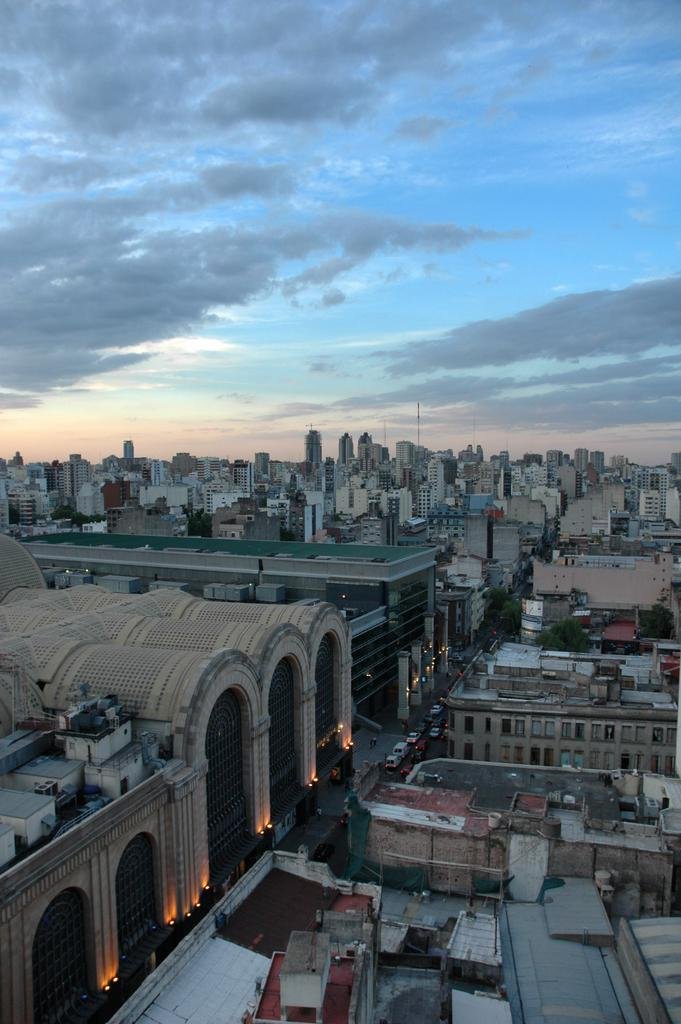What type of scene is depicted in the image? The image shows a view of the city. What structures can be seen in the cityscape? There are buildings visible in the image. What is happening on the road in the image? There is a road with vehicles in the image. What can be seen in the sky in the image? Clouds are present in the sky in the image. What type of advertisement can be seen on the side of the building in the image? There is no advertisement visible on the side of any building in the image. What force is causing the thrill in the image? There is no indication of any force or thrill in the image; it simply shows a view of the city with buildings, roads, vehicles, and clouds. 